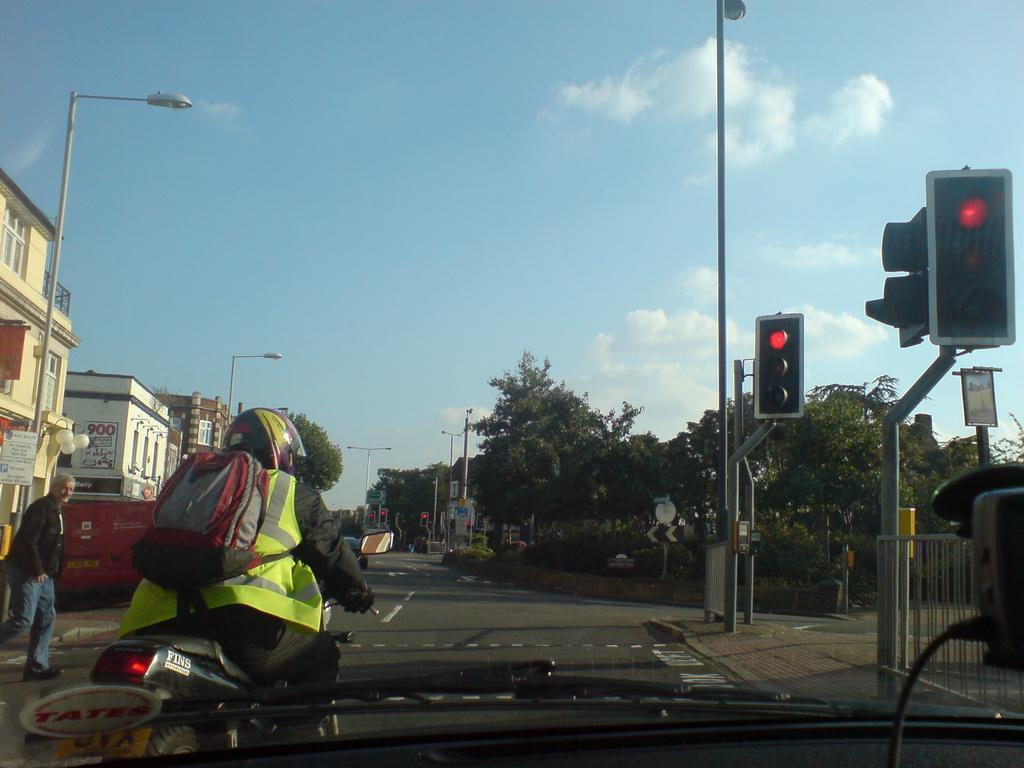Describe this image in one or two sentences. In this picture I can see a person riding a vehicle, there is a transparent glass with wiper blades, there is a man standing, there are buildings, there are poles, lights, boards, there are trees, and in the background there is the sky. 